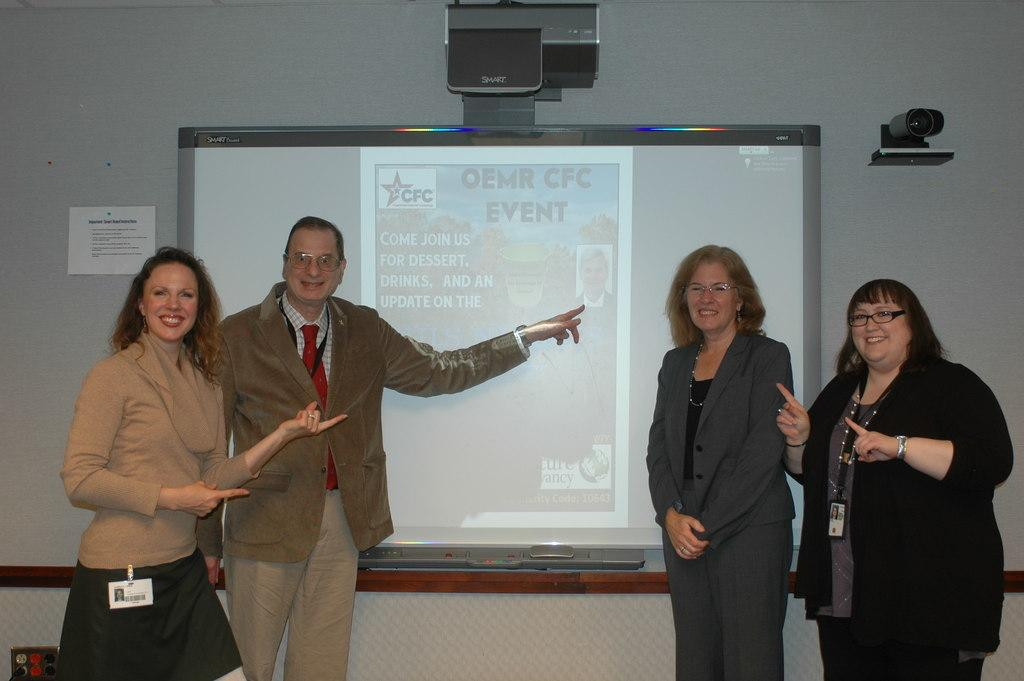What are the people in the image doing? The people in the image are standing and smiling. What can be seen in the background of the image? There is a screen and a wall in the background of the image. What is on the wall in the image? There is a paper pasted on the wall. Where is the light located in the image? The light is on the right side of the image. What type of silver bucket can be seen in the image? There is no silver bucket present in the image. 